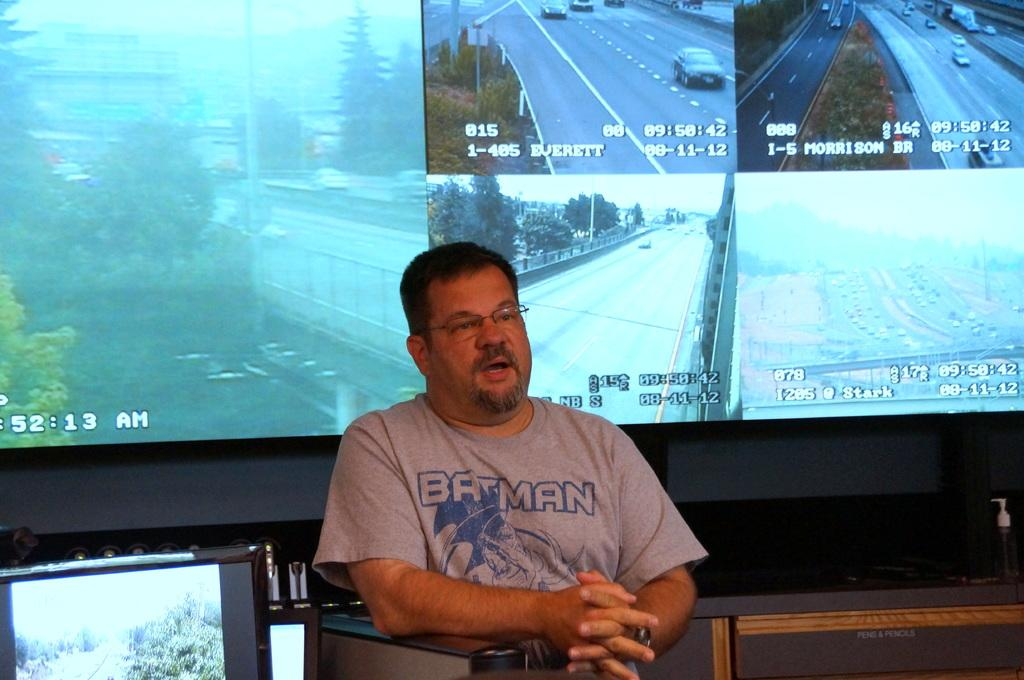What is the person in the image doing? There is a person sitting in the image. What can be seen in the background of the image? There is a screen in the background of the image. Where is the monitor located in the image? There is a monitor on the left side bottom of the image. What decision does the person make while sitting on the railway in the image? There is no railway present in the image, and the person's decision-making process is not depicted. 